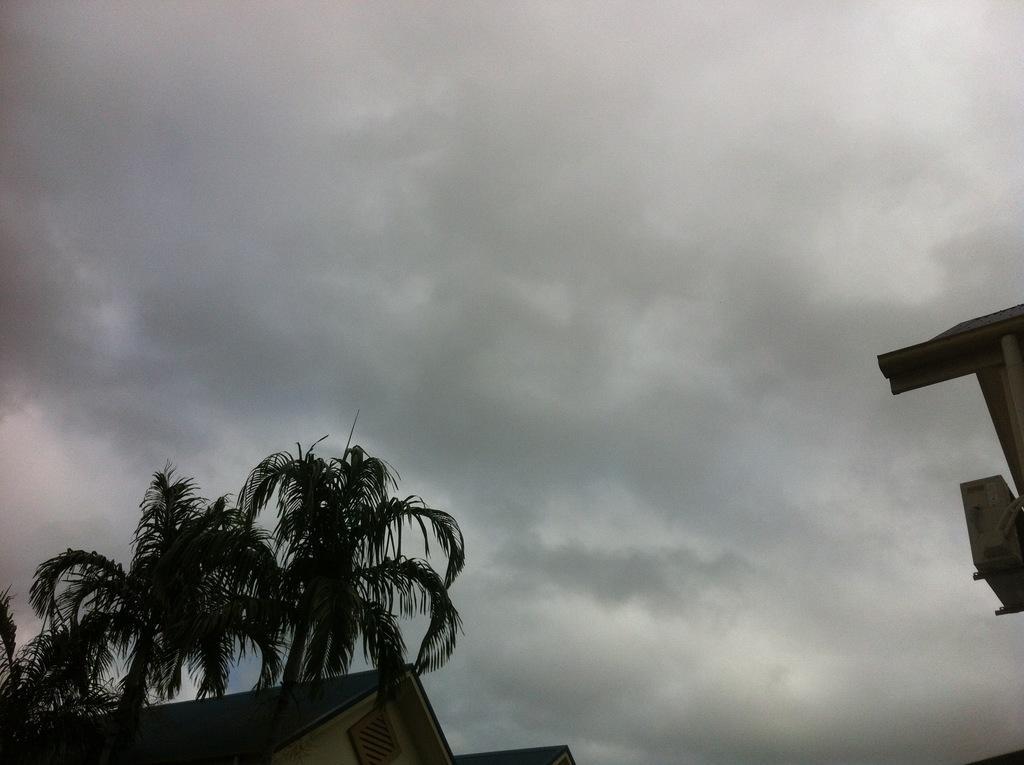How would you summarize this image in a sentence or two? In this picture, those two are looking like houses. In front of the house there are trees. Behind the houses there is the cloudy sky. 